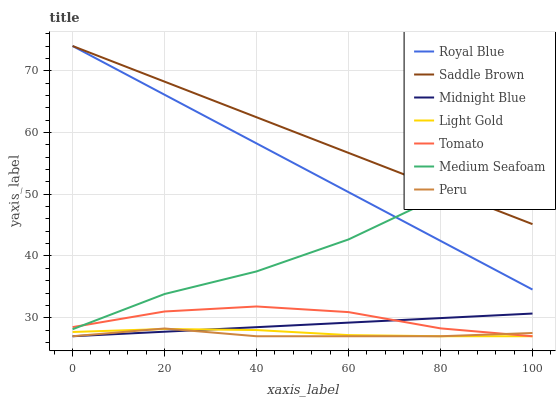Does Peru have the minimum area under the curve?
Answer yes or no. Yes. Does Saddle Brown have the maximum area under the curve?
Answer yes or no. Yes. Does Midnight Blue have the minimum area under the curve?
Answer yes or no. No. Does Midnight Blue have the maximum area under the curve?
Answer yes or no. No. Is Midnight Blue the smoothest?
Answer yes or no. Yes. Is Medium Seafoam the roughest?
Answer yes or no. Yes. Is Saddle Brown the smoothest?
Answer yes or no. No. Is Saddle Brown the roughest?
Answer yes or no. No. Does Tomato have the lowest value?
Answer yes or no. Yes. Does Saddle Brown have the lowest value?
Answer yes or no. No. Does Royal Blue have the highest value?
Answer yes or no. Yes. Does Midnight Blue have the highest value?
Answer yes or no. No. Is Tomato less than Royal Blue?
Answer yes or no. Yes. Is Royal Blue greater than Light Gold?
Answer yes or no. Yes. Does Light Gold intersect Tomato?
Answer yes or no. Yes. Is Light Gold less than Tomato?
Answer yes or no. No. Is Light Gold greater than Tomato?
Answer yes or no. No. Does Tomato intersect Royal Blue?
Answer yes or no. No. 